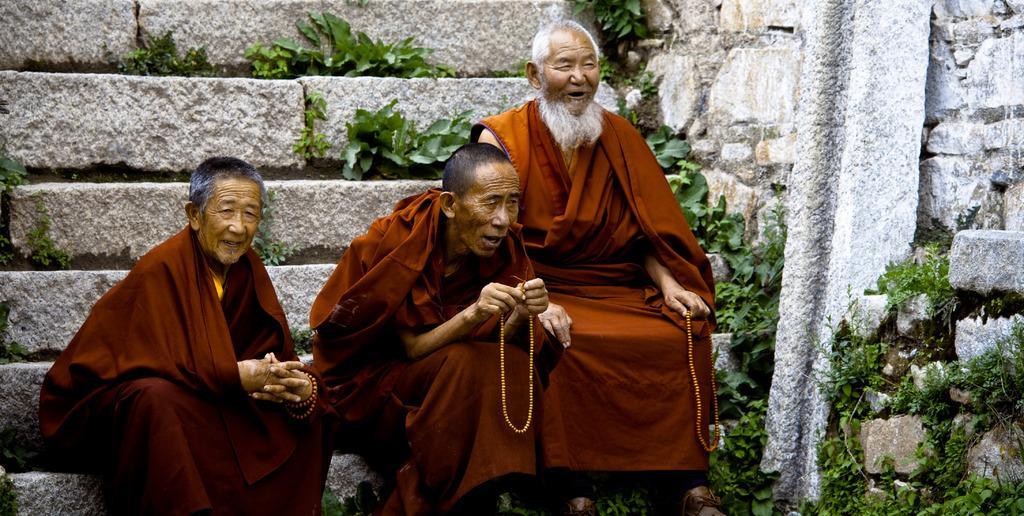How would you summarize this image in a sentence or two? In this image there are three people sitting on the steps in which two them are holding chains, there are few plants, a stone pillar and wall. 